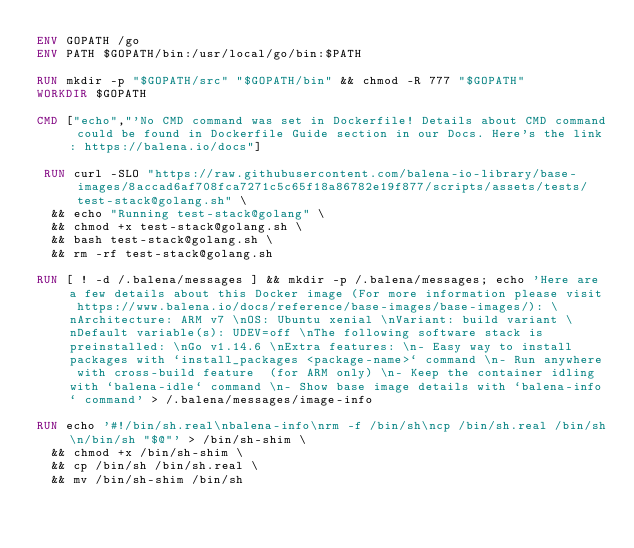<code> <loc_0><loc_0><loc_500><loc_500><_Dockerfile_>ENV GOPATH /go
ENV PATH $GOPATH/bin:/usr/local/go/bin:$PATH

RUN mkdir -p "$GOPATH/src" "$GOPATH/bin" && chmod -R 777 "$GOPATH"
WORKDIR $GOPATH

CMD ["echo","'No CMD command was set in Dockerfile! Details about CMD command could be found in Dockerfile Guide section in our Docs. Here's the link: https://balena.io/docs"]

 RUN curl -SLO "https://raw.githubusercontent.com/balena-io-library/base-images/8accad6af708fca7271c5c65f18a86782e19f877/scripts/assets/tests/test-stack@golang.sh" \
  && echo "Running test-stack@golang" \
  && chmod +x test-stack@golang.sh \
  && bash test-stack@golang.sh \
  && rm -rf test-stack@golang.sh 

RUN [ ! -d /.balena/messages ] && mkdir -p /.balena/messages; echo 'Here are a few details about this Docker image (For more information please visit https://www.balena.io/docs/reference/base-images/base-images/): \nArchitecture: ARM v7 \nOS: Ubuntu xenial \nVariant: build variant \nDefault variable(s): UDEV=off \nThe following software stack is preinstalled: \nGo v1.14.6 \nExtra features: \n- Easy way to install packages with `install_packages <package-name>` command \n- Run anywhere with cross-build feature  (for ARM only) \n- Keep the container idling with `balena-idle` command \n- Show base image details with `balena-info` command' > /.balena/messages/image-info

RUN echo '#!/bin/sh.real\nbalena-info\nrm -f /bin/sh\ncp /bin/sh.real /bin/sh\n/bin/sh "$@"' > /bin/sh-shim \
	&& chmod +x /bin/sh-shim \
	&& cp /bin/sh /bin/sh.real \
	&& mv /bin/sh-shim /bin/sh</code> 